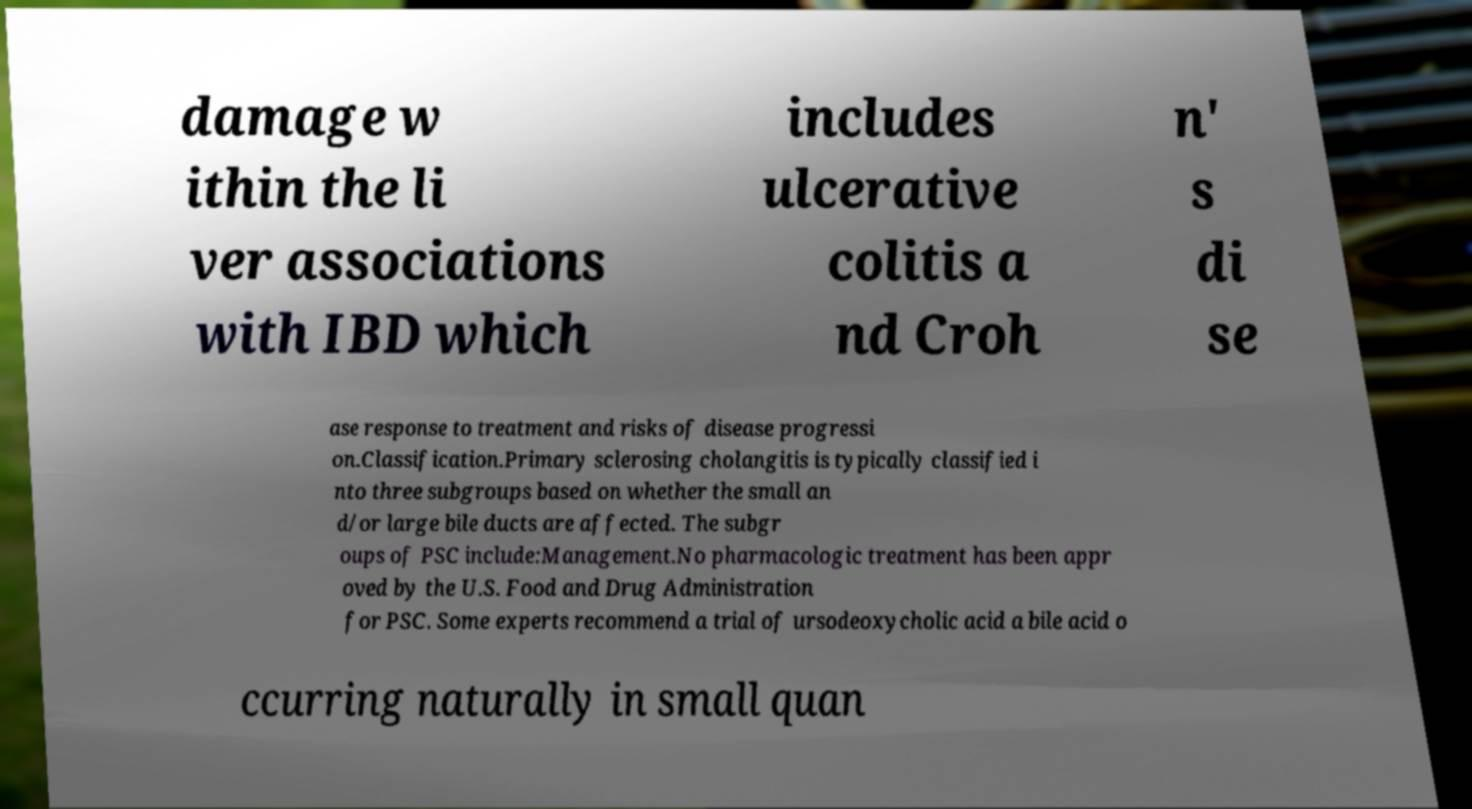Can you read and provide the text displayed in the image?This photo seems to have some interesting text. Can you extract and type it out for me? damage w ithin the li ver associations with IBD which includes ulcerative colitis a nd Croh n' s di se ase response to treatment and risks of disease progressi on.Classification.Primary sclerosing cholangitis is typically classified i nto three subgroups based on whether the small an d/or large bile ducts are affected. The subgr oups of PSC include:Management.No pharmacologic treatment has been appr oved by the U.S. Food and Drug Administration for PSC. Some experts recommend a trial of ursodeoxycholic acid a bile acid o ccurring naturally in small quan 